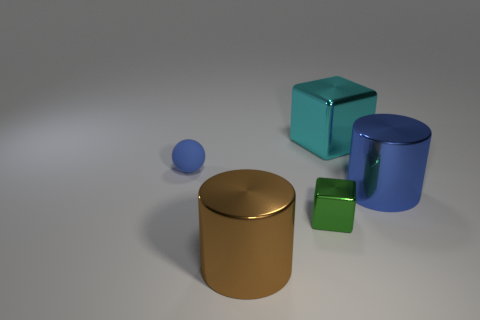The cylinder that is the same color as the sphere is what size?
Your response must be concise. Large. Does the small rubber thing have the same color as the big shiny cylinder that is to the right of the brown thing?
Your response must be concise. Yes. Is the number of blocks that are on the right side of the cyan cube less than the number of small metal blocks that are behind the green cube?
Offer a terse response. No. What material is the thing that is the same color as the sphere?
Offer a very short reply. Metal. What number of things are small green metal things to the right of the brown object or brown shiny things?
Make the answer very short. 2. There is a thing that is behind the matte thing; is it the same size as the brown shiny object?
Your response must be concise. Yes. Are there fewer shiny blocks that are on the right side of the blue cylinder than metallic blocks?
Keep it short and to the point. Yes. There is a ball that is the same size as the green block; what is it made of?
Keep it short and to the point. Rubber. What number of large things are either cyan metallic objects or shiny things?
Your answer should be compact. 3. What number of things are blocks behind the blue metallic cylinder or things that are right of the tiny ball?
Keep it short and to the point. 4. 